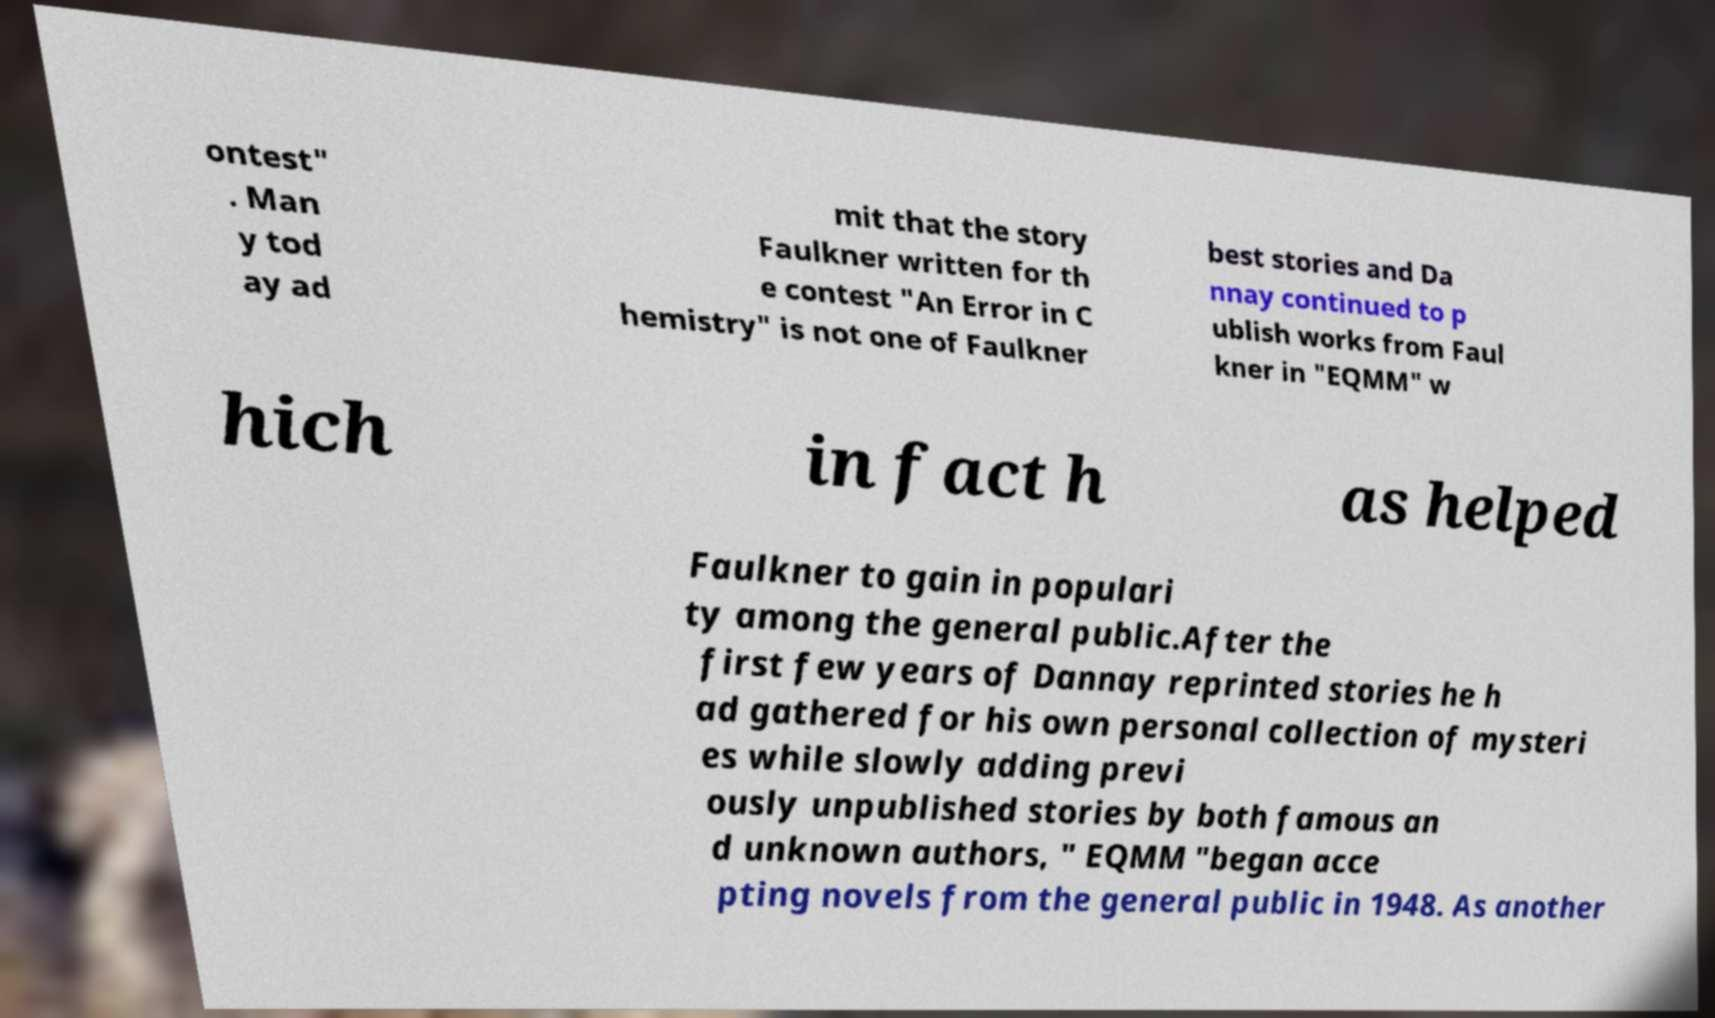I need the written content from this picture converted into text. Can you do that? ontest" . Man y tod ay ad mit that the story Faulkner written for th e contest "An Error in C hemistry" is not one of Faulkner best stories and Da nnay continued to p ublish works from Faul kner in "EQMM" w hich in fact h as helped Faulkner to gain in populari ty among the general public.After the first few years of Dannay reprinted stories he h ad gathered for his own personal collection of mysteri es while slowly adding previ ously unpublished stories by both famous an d unknown authors, " EQMM "began acce pting novels from the general public in 1948. As another 